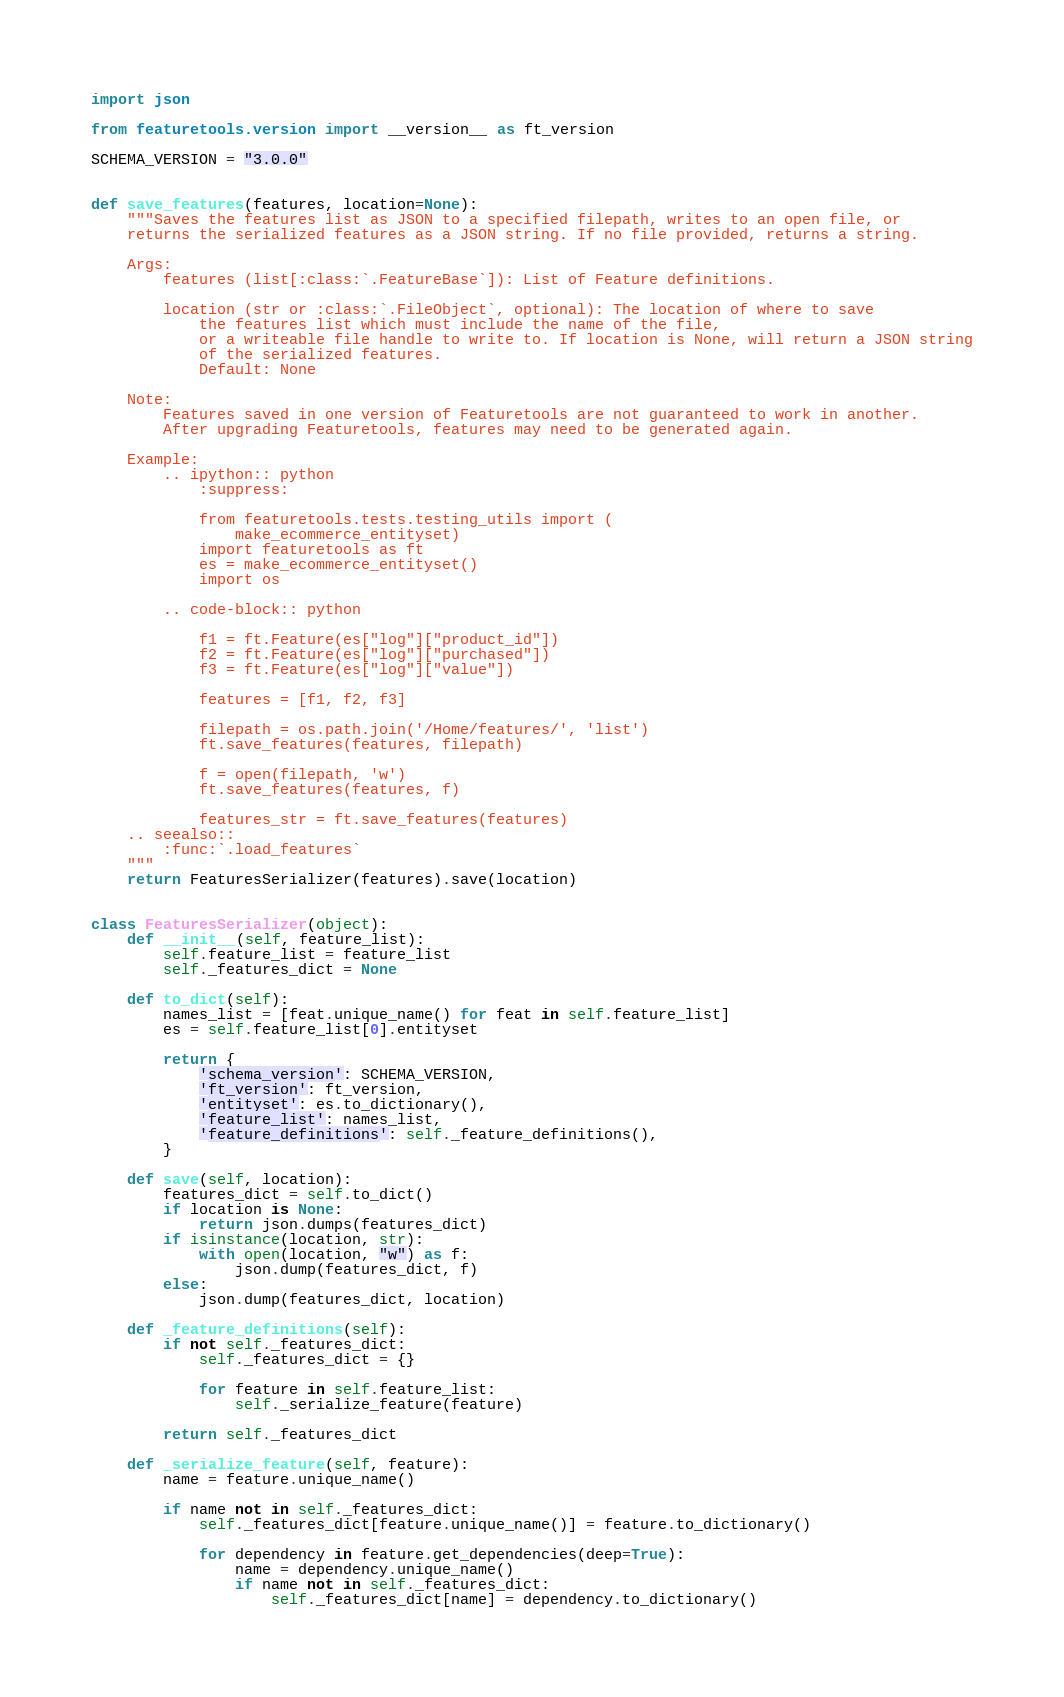Convert code to text. <code><loc_0><loc_0><loc_500><loc_500><_Python_>import json

from featuretools.version import __version__ as ft_version

SCHEMA_VERSION = "3.0.0"


def save_features(features, location=None):
    """Saves the features list as JSON to a specified filepath, writes to an open file, or
    returns the serialized features as a JSON string. If no file provided, returns a string.

    Args:
        features (list[:class:`.FeatureBase`]): List of Feature definitions.

        location (str or :class:`.FileObject`, optional): The location of where to save
            the features list which must include the name of the file,
            or a writeable file handle to write to. If location is None, will return a JSON string
            of the serialized features.
            Default: None

    Note:
        Features saved in one version of Featuretools are not guaranteed to work in another.
        After upgrading Featuretools, features may need to be generated again.

    Example:
        .. ipython:: python
            :suppress:

            from featuretools.tests.testing_utils import (
                make_ecommerce_entityset)
            import featuretools as ft
            es = make_ecommerce_entityset()
            import os

        .. code-block:: python

            f1 = ft.Feature(es["log"]["product_id"])
            f2 = ft.Feature(es["log"]["purchased"])
            f3 = ft.Feature(es["log"]["value"])

            features = [f1, f2, f3]

            filepath = os.path.join('/Home/features/', 'list')
            ft.save_features(features, filepath)

            f = open(filepath, 'w')
            ft.save_features(features, f)

            features_str = ft.save_features(features)
    .. seealso::
        :func:`.load_features`
    """
    return FeaturesSerializer(features).save(location)


class FeaturesSerializer(object):
    def __init__(self, feature_list):
        self.feature_list = feature_list
        self._features_dict = None

    def to_dict(self):
        names_list = [feat.unique_name() for feat in self.feature_list]
        es = self.feature_list[0].entityset

        return {
            'schema_version': SCHEMA_VERSION,
            'ft_version': ft_version,
            'entityset': es.to_dictionary(),
            'feature_list': names_list,
            'feature_definitions': self._feature_definitions(),
        }

    def save(self, location):
        features_dict = self.to_dict()
        if location is None:
            return json.dumps(features_dict)
        if isinstance(location, str):
            with open(location, "w") as f:
                json.dump(features_dict, f)
        else:
            json.dump(features_dict, location)

    def _feature_definitions(self):
        if not self._features_dict:
            self._features_dict = {}

            for feature in self.feature_list:
                self._serialize_feature(feature)

        return self._features_dict

    def _serialize_feature(self, feature):
        name = feature.unique_name()

        if name not in self._features_dict:
            self._features_dict[feature.unique_name()] = feature.to_dictionary()

            for dependency in feature.get_dependencies(deep=True):
                name = dependency.unique_name()
                if name not in self._features_dict:
                    self._features_dict[name] = dependency.to_dictionary()
</code> 